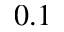<formula> <loc_0><loc_0><loc_500><loc_500>0 . 1</formula> 